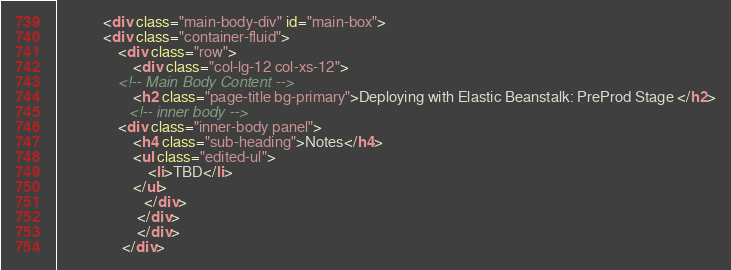<code> <loc_0><loc_0><loc_500><loc_500><_HTML_>            <div class="main-body-div" id="main-box">
            <div class="container-fluid">
                <div class="row">
                    <div class="col-lg-12 col-xs-12">
                <!-- Main Body Content -->
                    <h2 class="page-title bg-primary">Deploying with Elastic Beanstalk: PreProd Stage </h2>
                   <!-- inner body -->
                <div class="inner-body panel">
                    <h4 class="sub-heading">Notes</h4>
                    <ul class="edited-ul">
                        <li>TBD</li>
                    </ul>
                       </div>  
                     </div>
                     </div>
                 </div>  </code> 